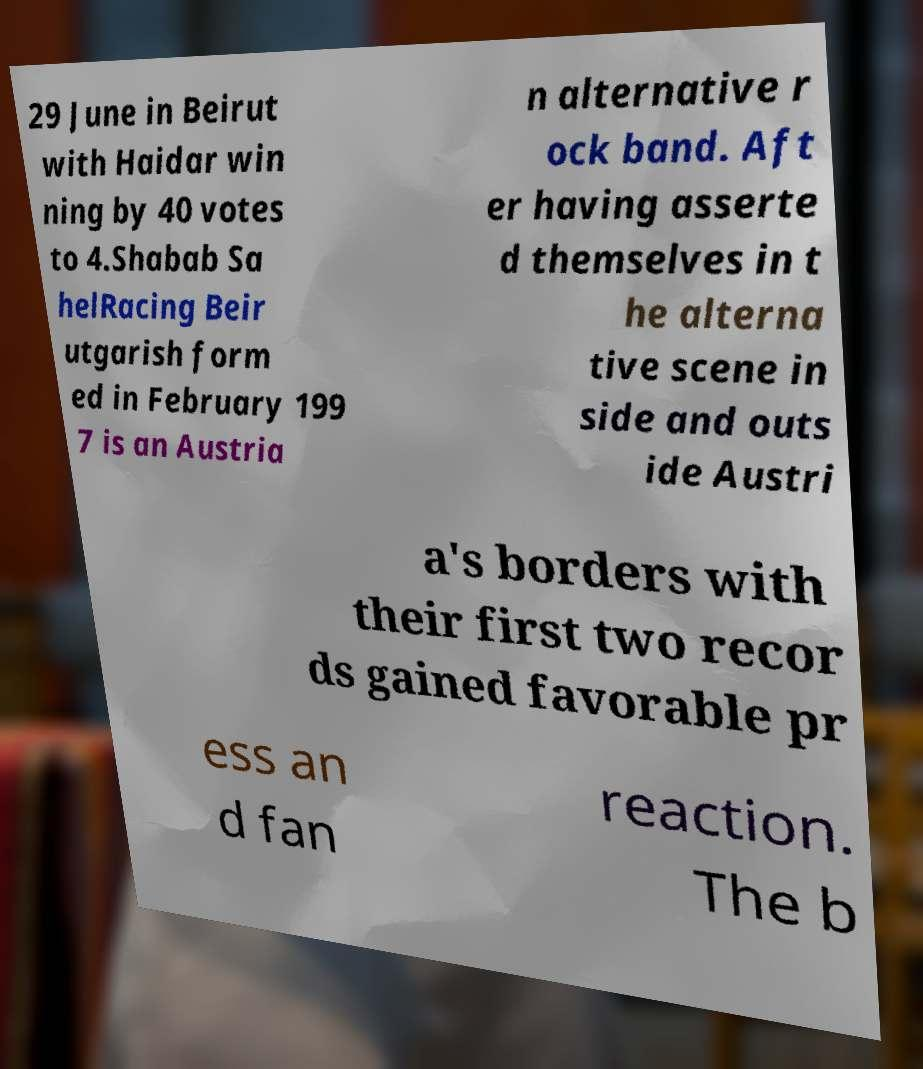Can you accurately transcribe the text from the provided image for me? 29 June in Beirut with Haidar win ning by 40 votes to 4.Shabab Sa helRacing Beir utgarish form ed in February 199 7 is an Austria n alternative r ock band. Aft er having asserte d themselves in t he alterna tive scene in side and outs ide Austri a's borders with their first two recor ds gained favorable pr ess an d fan reaction. The b 